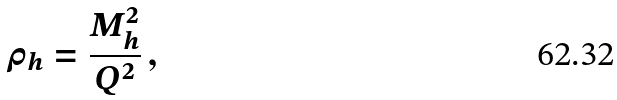Convert formula to latex. <formula><loc_0><loc_0><loc_500><loc_500>\rho _ { h } = \frac { M _ { h } ^ { 2 } } { Q ^ { 2 } } \, ,</formula> 